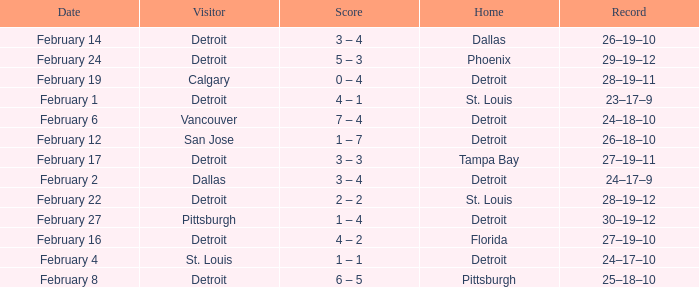What was their record on February 24? 29–19–12. 